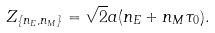<formula> <loc_0><loc_0><loc_500><loc_500>Z _ { \{ n _ { E } , n _ { M } \} } = \sqrt { 2 } a ( n _ { E } + n _ { M } \tau _ { 0 } ) .</formula> 